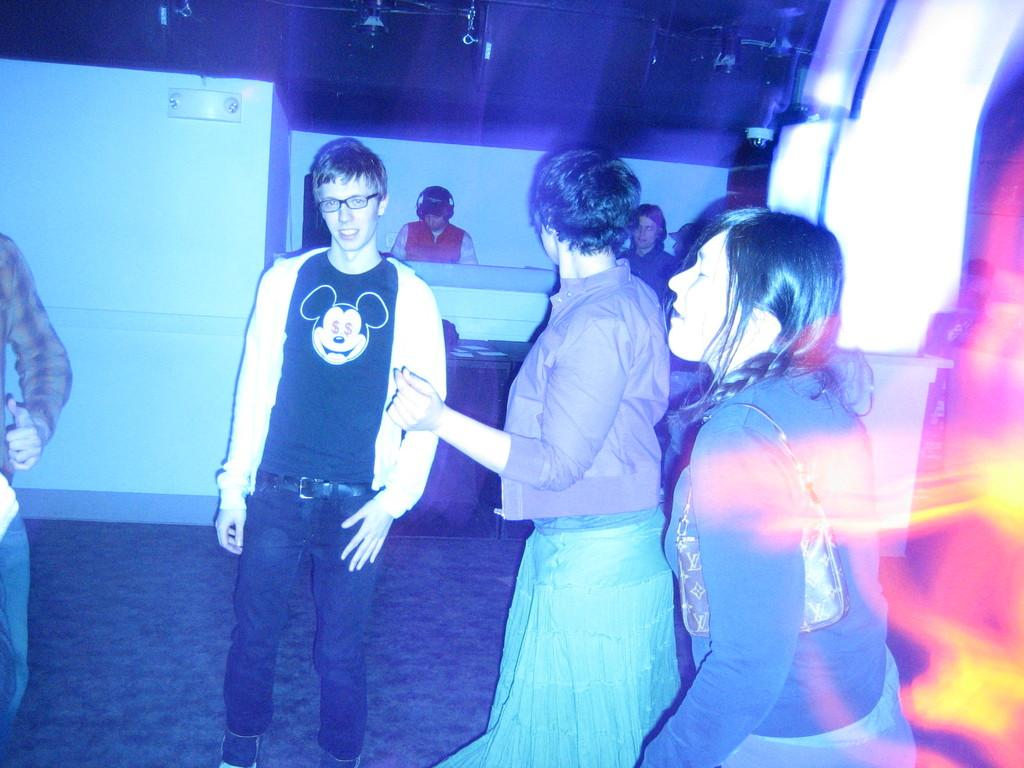How many people are in the image? There is a group of people standing in the image. What is the surface on which the people are standing? The people are standing on the floor. Can you identify any specific accessories worn by some of the people? Yes, there are two people wearing headsets in the image. What type of structure can be seen in the background of the image? There is a wall and a roof visible in the image. What type of flesh can be seen hanging from the wall in the image? There is no flesh visible in the image; the wall is a part of a structure. 